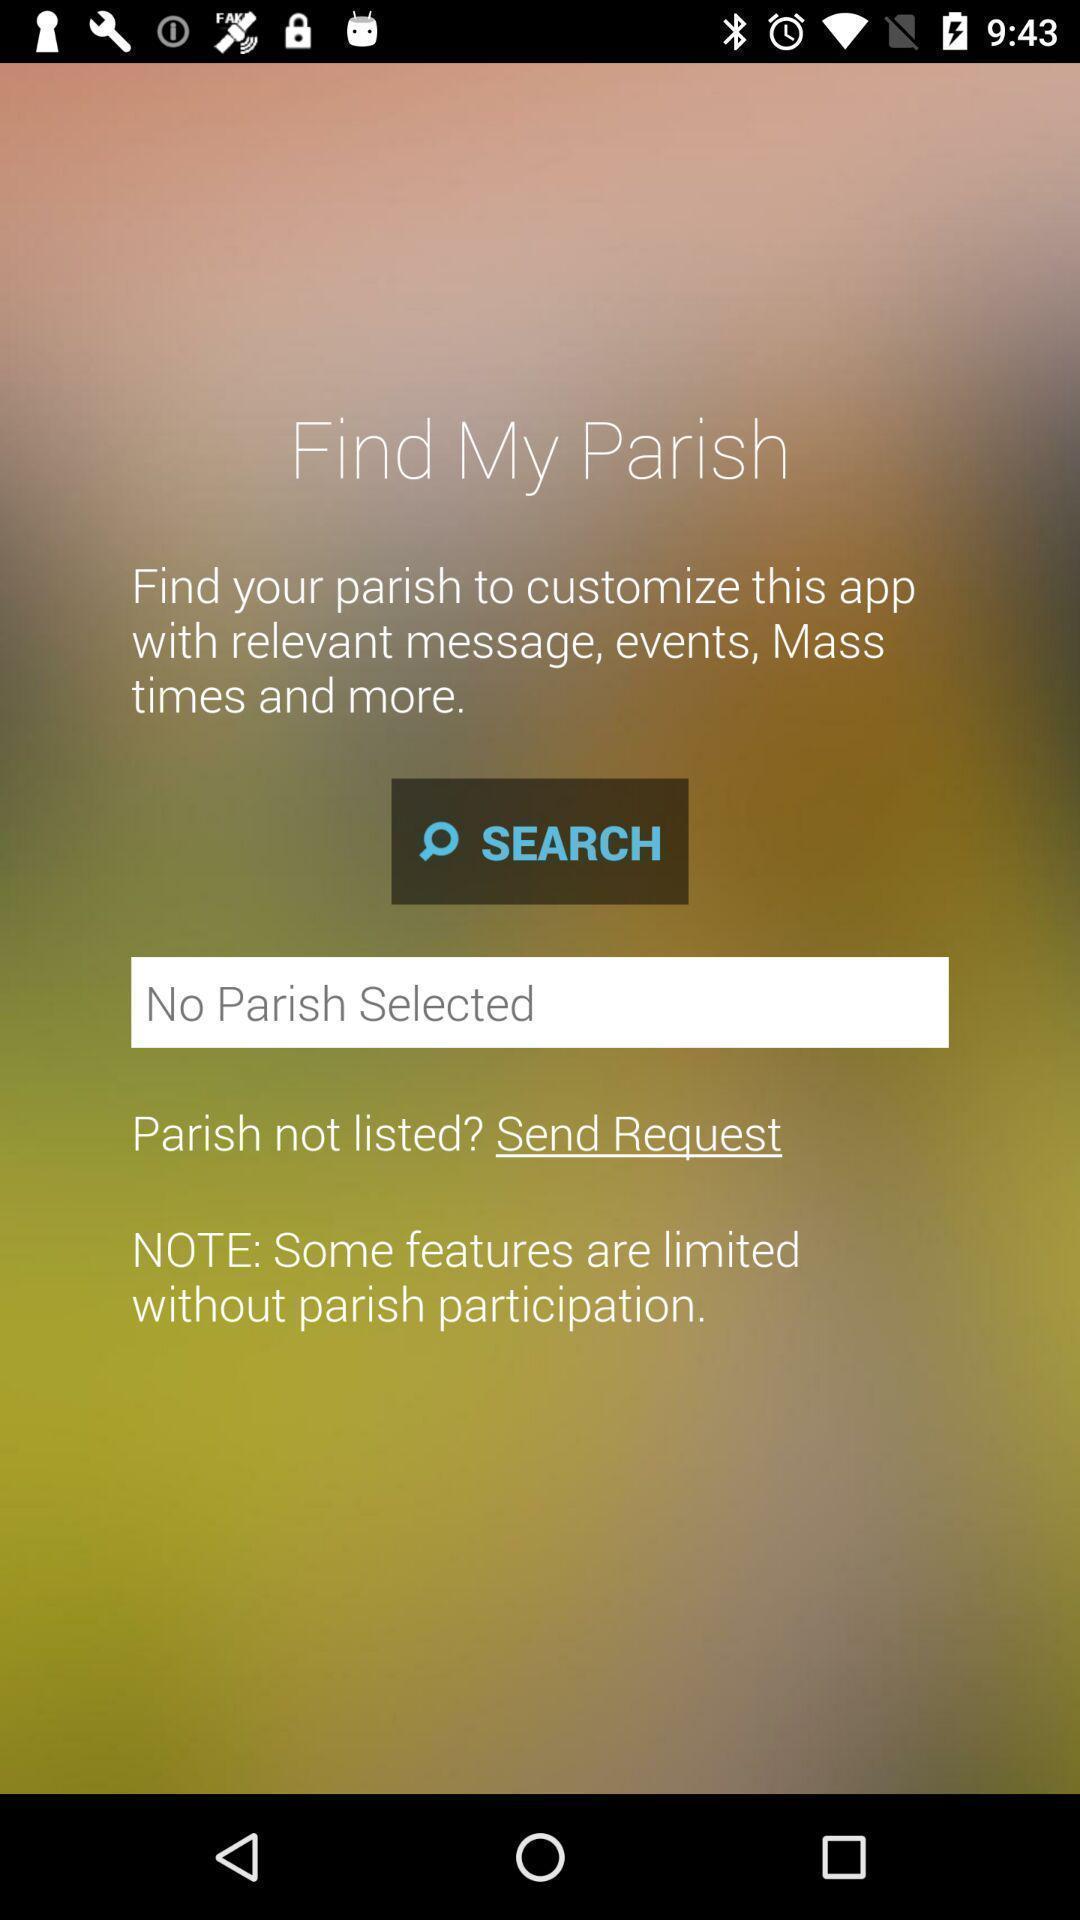Describe this image in words. Welcome page displaying to find parish. 